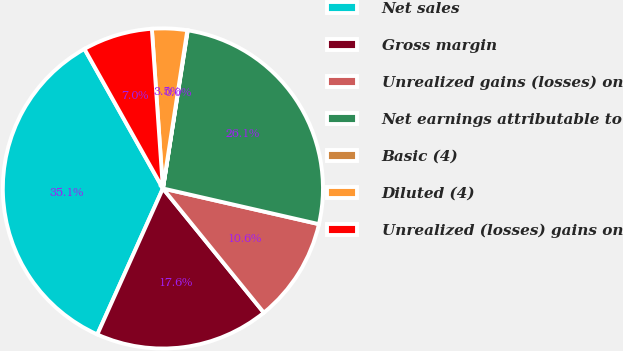<chart> <loc_0><loc_0><loc_500><loc_500><pie_chart><fcel>Net sales<fcel>Gross margin<fcel>Unrealized gains (losses) on<fcel>Net earnings attributable to<fcel>Basic (4)<fcel>Diluted (4)<fcel>Unrealized (losses) gains on<nl><fcel>35.13%<fcel>17.58%<fcel>10.56%<fcel>26.1%<fcel>0.04%<fcel>3.54%<fcel>7.05%<nl></chart> 